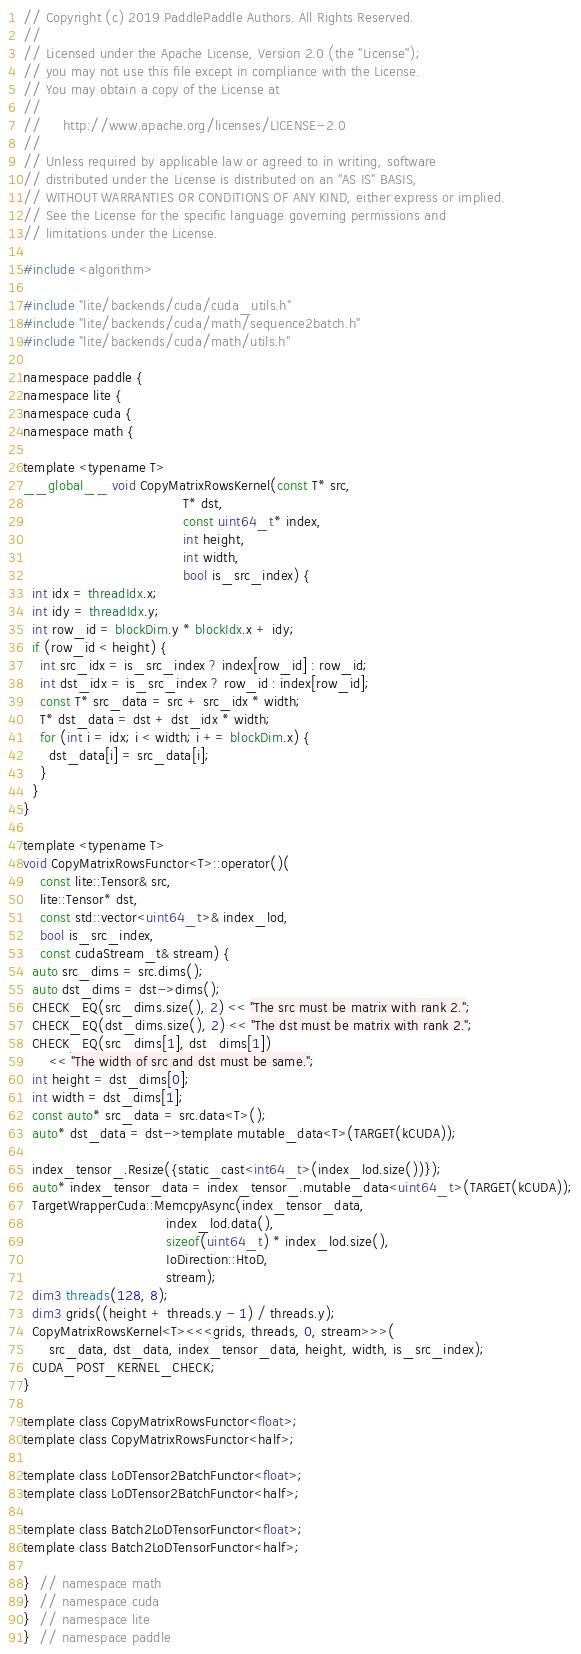<code> <loc_0><loc_0><loc_500><loc_500><_Cuda_>// Copyright (c) 2019 PaddlePaddle Authors. All Rights Reserved.
//
// Licensed under the Apache License, Version 2.0 (the "License");
// you may not use this file except in compliance with the License.
// You may obtain a copy of the License at
//
//     http://www.apache.org/licenses/LICENSE-2.0
//
// Unless required by applicable law or agreed to in writing, software
// distributed under the License is distributed on an "AS IS" BASIS,
// WITHOUT WARRANTIES OR CONDITIONS OF ANY KIND, either express or implied.
// See the License for the specific language governing permissions and
// limitations under the License.

#include <algorithm>

#include "lite/backends/cuda/cuda_utils.h"
#include "lite/backends/cuda/math/sequence2batch.h"
#include "lite/backends/cuda/math/utils.h"

namespace paddle {
namespace lite {
namespace cuda {
namespace math {

template <typename T>
__global__ void CopyMatrixRowsKernel(const T* src,
                                     T* dst,
                                     const uint64_t* index,
                                     int height,
                                     int width,
                                     bool is_src_index) {
  int idx = threadIdx.x;
  int idy = threadIdx.y;
  int row_id = blockDim.y * blockIdx.x + idy;
  if (row_id < height) {
    int src_idx = is_src_index ? index[row_id] : row_id;
    int dst_idx = is_src_index ? row_id : index[row_id];
    const T* src_data = src + src_idx * width;
    T* dst_data = dst + dst_idx * width;
    for (int i = idx; i < width; i += blockDim.x) {
      dst_data[i] = src_data[i];
    }
  }
}

template <typename T>
void CopyMatrixRowsFunctor<T>::operator()(
    const lite::Tensor& src,
    lite::Tensor* dst,
    const std::vector<uint64_t>& index_lod,
    bool is_src_index,
    const cudaStream_t& stream) {
  auto src_dims = src.dims();
  auto dst_dims = dst->dims();
  CHECK_EQ(src_dims.size(), 2) << "The src must be matrix with rank 2.";
  CHECK_EQ(dst_dims.size(), 2) << "The dst must be matrix with rank 2.";
  CHECK_EQ(src_dims[1], dst_dims[1])
      << "The width of src and dst must be same.";
  int height = dst_dims[0];
  int width = dst_dims[1];
  const auto* src_data = src.data<T>();
  auto* dst_data = dst->template mutable_data<T>(TARGET(kCUDA));

  index_tensor_.Resize({static_cast<int64_t>(index_lod.size())});
  auto* index_tensor_data = index_tensor_.mutable_data<uint64_t>(TARGET(kCUDA));
  TargetWrapperCuda::MemcpyAsync(index_tensor_data,
                                 index_lod.data(),
                                 sizeof(uint64_t) * index_lod.size(),
                                 IoDirection::HtoD,
                                 stream);
  dim3 threads(128, 8);
  dim3 grids((height + threads.y - 1) / threads.y);
  CopyMatrixRowsKernel<T><<<grids, threads, 0, stream>>>(
      src_data, dst_data, index_tensor_data, height, width, is_src_index);
  CUDA_POST_KERNEL_CHECK;
}

template class CopyMatrixRowsFunctor<float>;
template class CopyMatrixRowsFunctor<half>;

template class LoDTensor2BatchFunctor<float>;
template class LoDTensor2BatchFunctor<half>;

template class Batch2LoDTensorFunctor<float>;
template class Batch2LoDTensorFunctor<half>;

}  // namespace math
}  // namespace cuda
}  // namespace lite
}  // namespace paddle
</code> 